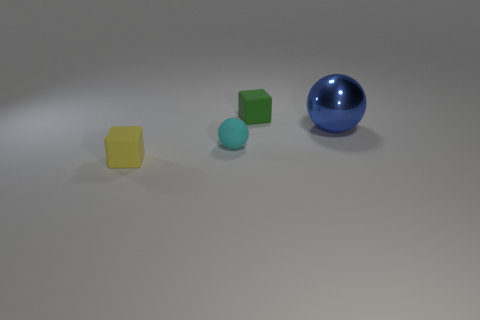Add 2 big blue cylinders. How many objects exist? 6 Subtract 1 cubes. How many cubes are left? 1 Subtract all yellow blocks. Subtract all red cylinders. How many blocks are left? 1 Subtract all green balls. How many yellow cubes are left? 1 Subtract all green cylinders. Subtract all tiny rubber objects. How many objects are left? 1 Add 2 large blue spheres. How many large blue spheres are left? 3 Add 2 big gray metal balls. How many big gray metal balls exist? 2 Subtract 0 green spheres. How many objects are left? 4 